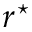Convert formula to latex. <formula><loc_0><loc_0><loc_500><loc_500>r ^ { ^ { * } }</formula> 